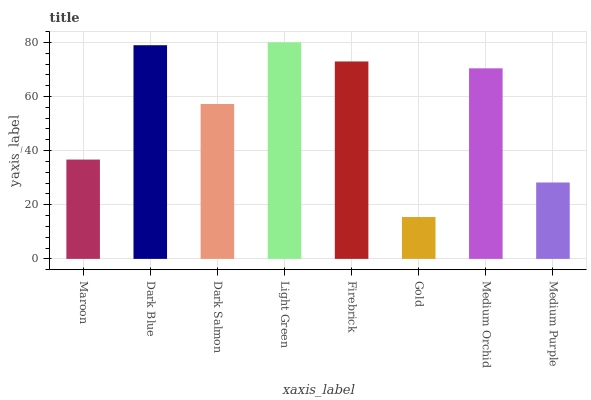Is Gold the minimum?
Answer yes or no. Yes. Is Light Green the maximum?
Answer yes or no. Yes. Is Dark Blue the minimum?
Answer yes or no. No. Is Dark Blue the maximum?
Answer yes or no. No. Is Dark Blue greater than Maroon?
Answer yes or no. Yes. Is Maroon less than Dark Blue?
Answer yes or no. Yes. Is Maroon greater than Dark Blue?
Answer yes or no. No. Is Dark Blue less than Maroon?
Answer yes or no. No. Is Medium Orchid the high median?
Answer yes or no. Yes. Is Dark Salmon the low median?
Answer yes or no. Yes. Is Medium Purple the high median?
Answer yes or no. No. Is Dark Blue the low median?
Answer yes or no. No. 